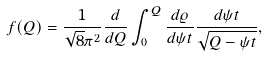Convert formula to latex. <formula><loc_0><loc_0><loc_500><loc_500>f ( Q ) = \frac { 1 } { \sqrt { 8 } \pi ^ { 2 } } \frac { d } { d Q } \int _ { 0 } ^ { Q } { \frac { d { \varrho } } { d \psi t } } { \frac { d \psi t } { \sqrt { Q - \psi t } } } ,</formula> 